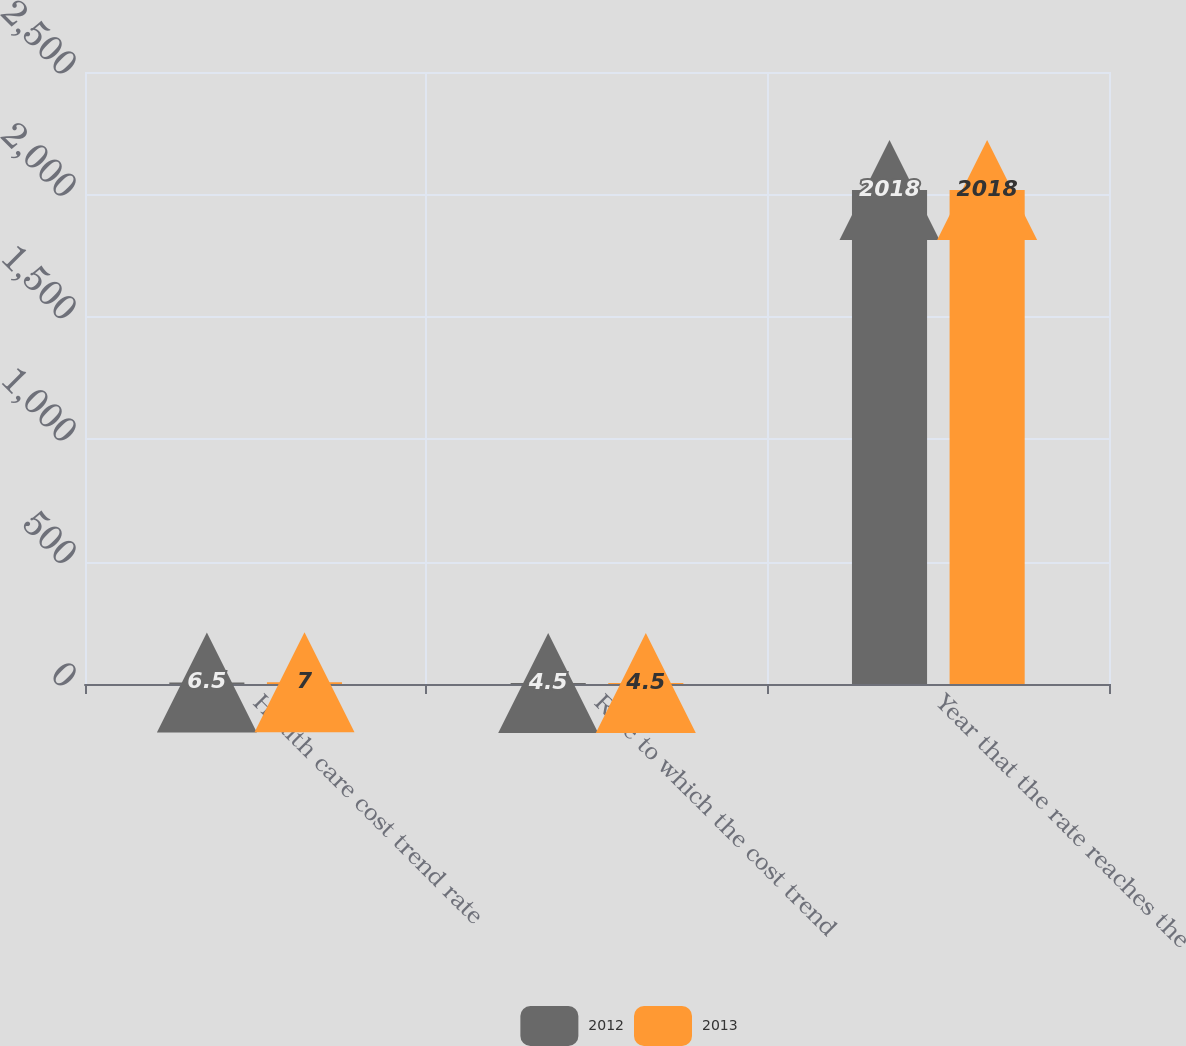<chart> <loc_0><loc_0><loc_500><loc_500><stacked_bar_chart><ecel><fcel>Health care cost trend rate<fcel>Rate to which the cost trend<fcel>Year that the rate reaches the<nl><fcel>2012<fcel>6.5<fcel>4.5<fcel>2018<nl><fcel>2013<fcel>7<fcel>4.5<fcel>2018<nl></chart> 